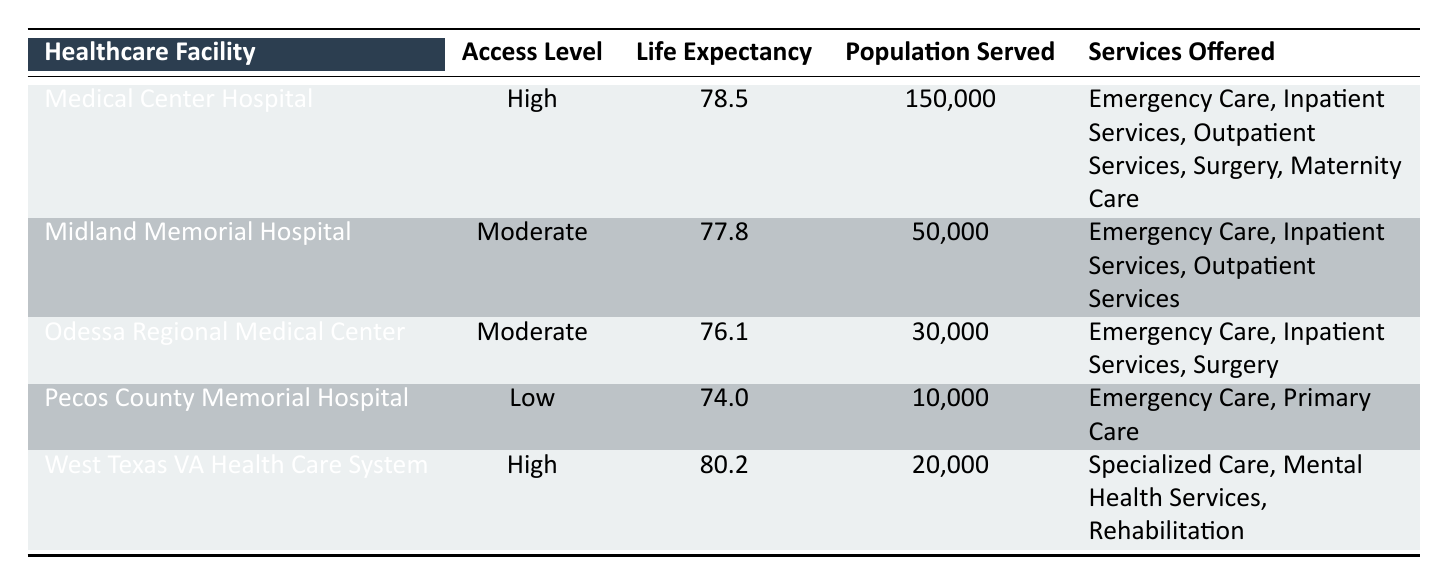What's the life expectancy at Medical Center Hospital? According to the table, the life expectancy for Medical Center Hospital is directly listed under the "Life Expectancy" column. It shows a value of 78.5 years.
Answer: 78.5 Which healthcare facility has the highest life expectancy? By comparing the values in the "Life Expectancy" column for all healthcare facilities, I see that West Texas VA Health Care System has the highest life expectancy at 80.2 years.
Answer: West Texas VA Health Care System What is the average life expectancy of facilities with high access levels? The life expectancies for the facilities with high access levels are 78.5 (Medical Center Hospital) and 80.2 (West Texas VA Health Care System). The average is calculated as (78.5 + 80.2) / 2 = 79.35.
Answer: 79.35 Is the life expectancy at Pecos County Memorial Hospital higher than that at Odessa Regional Medical Center? The life expectancy at Pecos County Memorial Hospital is 74.0 years, while that at Odessa Regional Medical Center is 76.1 years. Since 74.0 is less than 76.1, the answer is no.
Answer: No How many people does the Midland Memorial Hospital serve compared to the Pecos County Memorial Hospital? Midland Memorial Hospital serves 50,000 people while Pecos County Memorial Hospital serves 10,000 people. The difference in the population served is 50,000 - 10,000 = 40,000. Thus, Midland serves 40,000 more individuals.
Answer: 40,000 Does the Odessa Regional Medical Center offer maternity care? The services offered by Odessa Regional Medical Center include Emergency Care, Inpatient Services, and Surgery, but there is no mention of maternity care among these. Thus, the answer is no.
Answer: No What is the combined population served by all the high access healthcare facilities? The populations served by the high access facilities are 150,000 (Medical Center Hospital) and 20,000 (West Texas VA Health Care System). The total is 150,000 + 20,000 = 170,000.
Answer: 170,000 If we consider the services offered, which facility provides maternity care? The only facility listed with maternity care is Medical Center Hospital, as indicated in the "Services Offered" column. No other facility in the table mentions maternity care.
Answer: Medical Center Hospital What is the difference in life expectancy between facilities with low and moderate access levels? The life expectancy for low access (Pecos County Memorial Hospital) is 74.0 years and for moderate access (the average of Midland Memorial Hospital with 77.8 and Odessa Regional Medical Center with 76.1 is (77.8 + 76.1) / 2 = 76.95). The difference is 76.95 - 74.0 = 2.95 years.
Answer: 2.95 